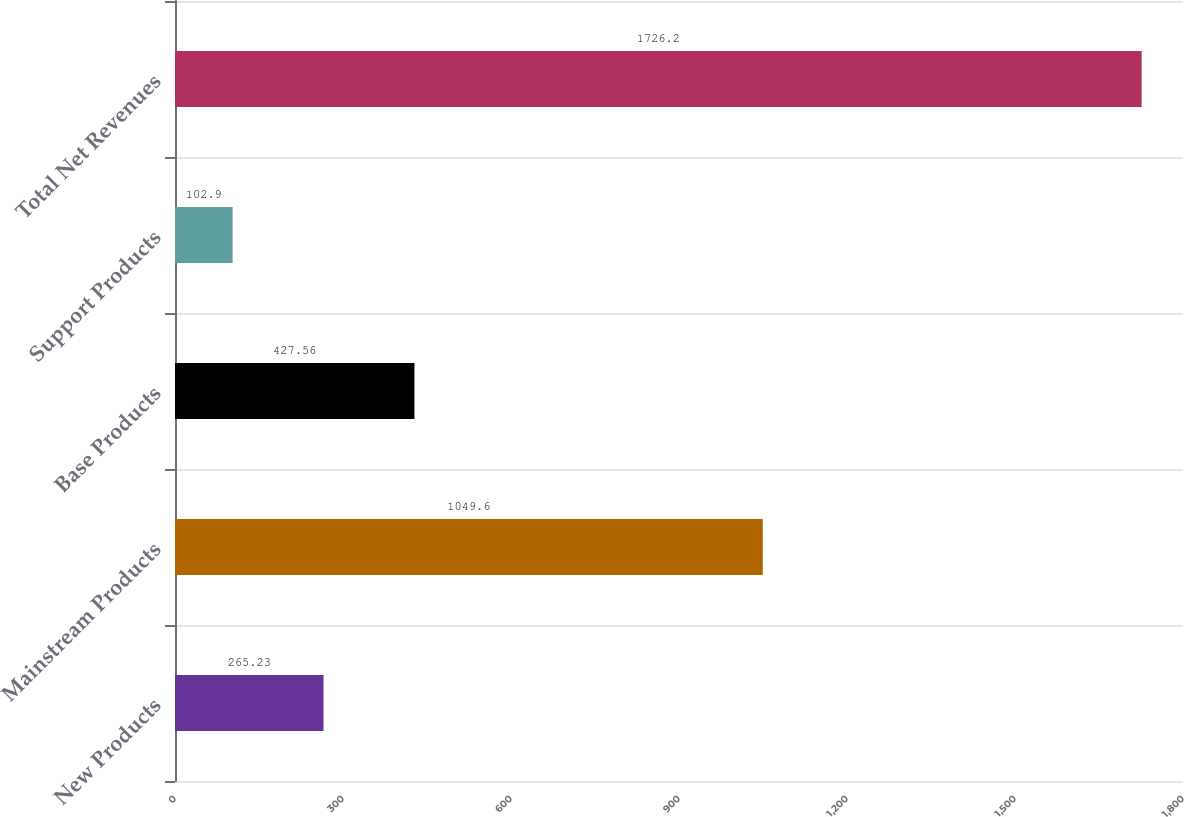<chart> <loc_0><loc_0><loc_500><loc_500><bar_chart><fcel>New Products<fcel>Mainstream Products<fcel>Base Products<fcel>Support Products<fcel>Total Net Revenues<nl><fcel>265.23<fcel>1049.6<fcel>427.56<fcel>102.9<fcel>1726.2<nl></chart> 